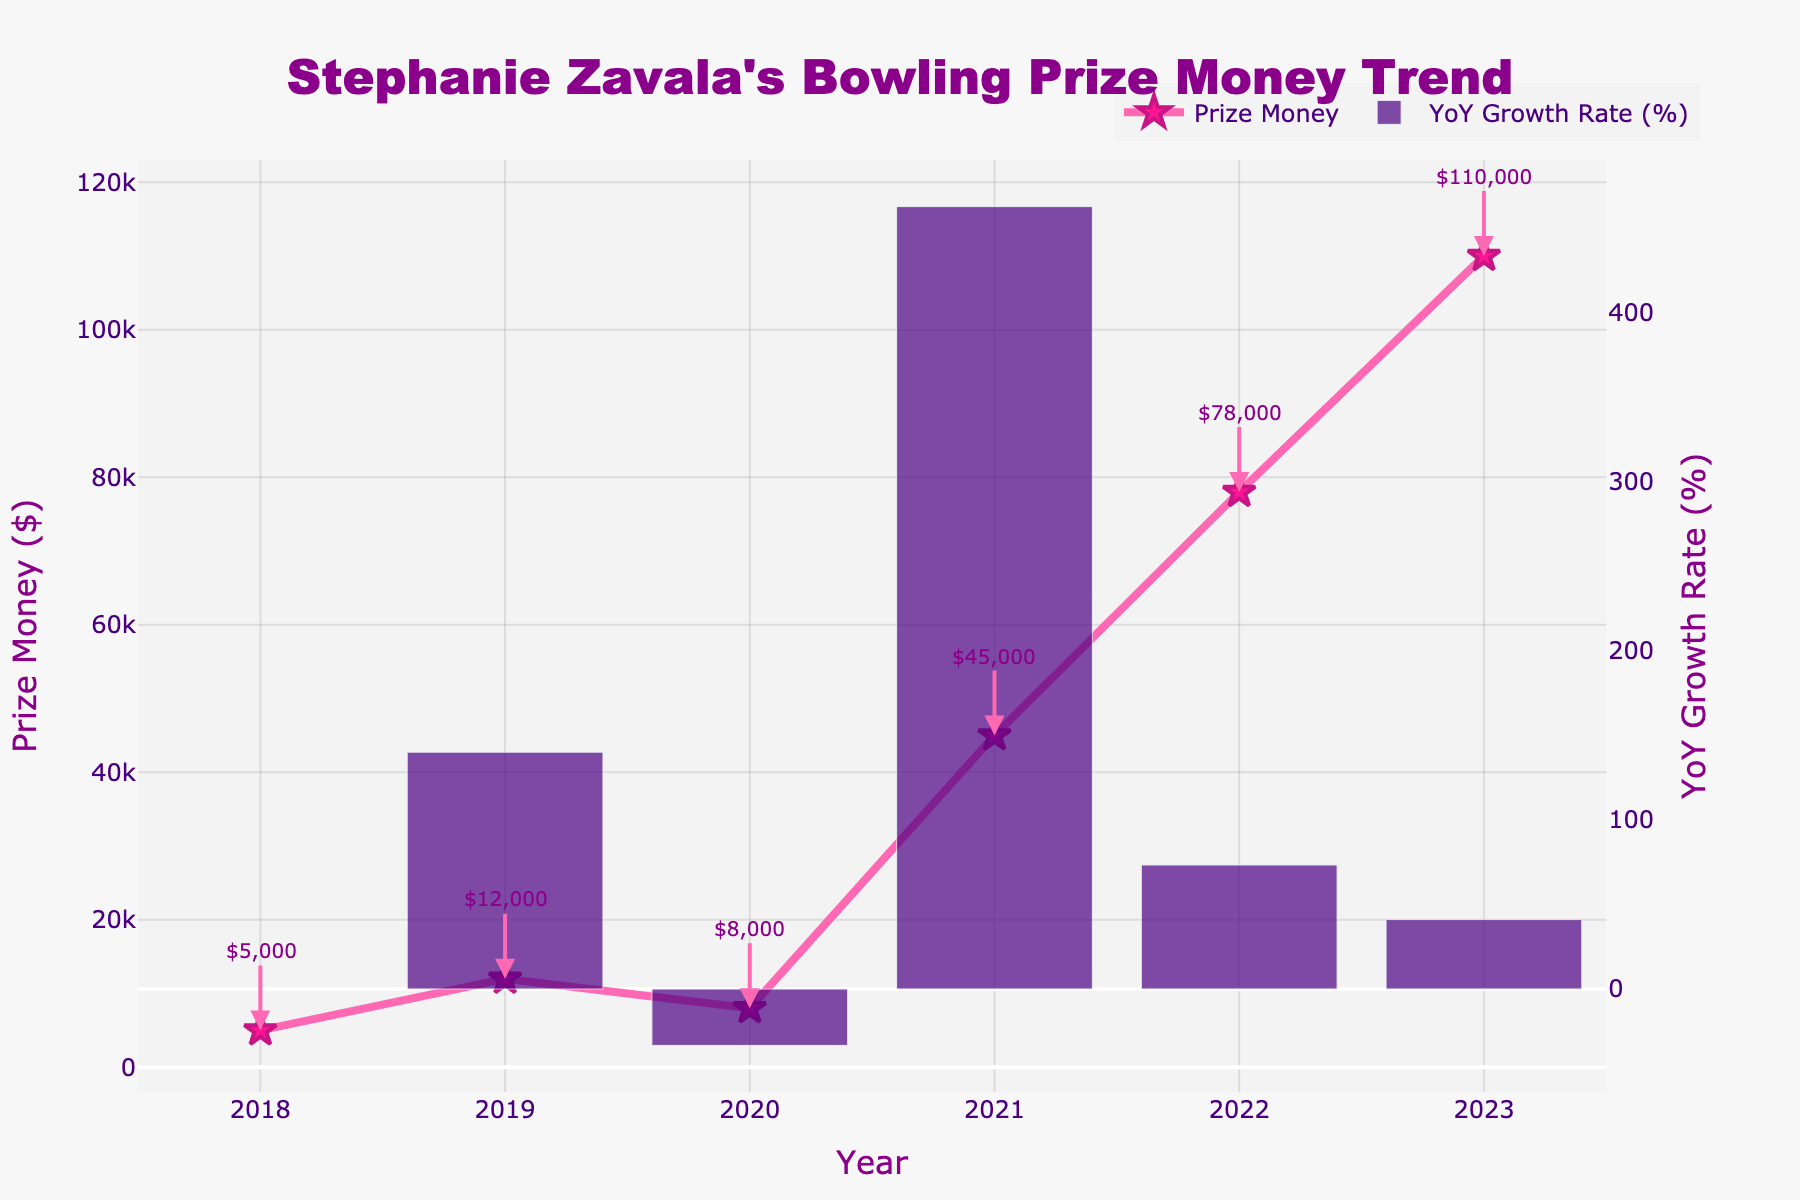What year did Stephanie Zavala earn the most prize money, and how much? By examining the chart, we can see that the highest prize money is represented by the tallest peak in 2023, which is labeled $110,000.
Answer: 2023, $110,000 How much more did Stephanie earn in 2021 compared to 2020? From the chart, the prize money for 2020 is $8,000, and for 2021, it's $45,000. The difference is calculated as $45,000 - $8,000.
Answer: $37,000 What was the percentage growth in prize money from 2021 to 2022? The chart includes a bar representing the YoY growth rate. For the year 2022, this bar shows a growth rate. This can be confirmed by reading the specific value from the chart, which is approximately 73.33%.
Answer: Approximately 73.33% During which years did Stephanie Zavala's prize money decrease? By observing the downwards dips between the peaks in the line chart, we can see that the prize money decreased from 2019 to 2020.
Answer: 2019 to 2020 What is the average prize money earned per year from 2018 to 2023? Add the prize money for each year: $5,000 + $12,000 + $8,000 + $45,000 + $78,000 + $110,000, then divide by the number of years (6). (5,000 + 12,000 + 8,000 + 45,000 + 78,000 + 110,000) / 6 = $43,000.
Answer: $43,000 Which two consecutive years had the highest growth rate in Stephanie's prize money? Look for the tallest bar in the YoY growth rate chart. The tallest bar corresponds to the growth rate from 2020 to 2021.
Answer: 2020 to 2021 What was the prize money in 2019, and how does it compare to the amount in 2018? Referring to the annotations, the prize money in 2019 was $12,000, and in 2018, it was $5,000. The comparison shows that 2019 had more prize money by $7,000.
Answer: 2019: $12,000, 2018: $5,000, difference: $7,000 How many times did Stephanie Zavala's prize money increase from the previous year? Check the trend line for segments where it moves upwards from one year to the next. There were increases in 2019, 2021, 2022, and 2023.
Answer: 4 times Which year shows the smallest amount of prize money earned? Identify the lowest point on the line graph; the lowest point is in 2018, labeled $5,000.
Answer: 2018, $5,000 What was the year-over-year growth rate in prize money from 2018 to 2019? Look at the bar in the growth rate chart for 2019, which represents the growth from 2018. This bar indicates around 140% growth.
Answer: Approximately 140% 